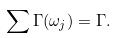<formula> <loc_0><loc_0><loc_500><loc_500>\sum \Gamma ( \omega _ { j } ) = \Gamma .</formula> 